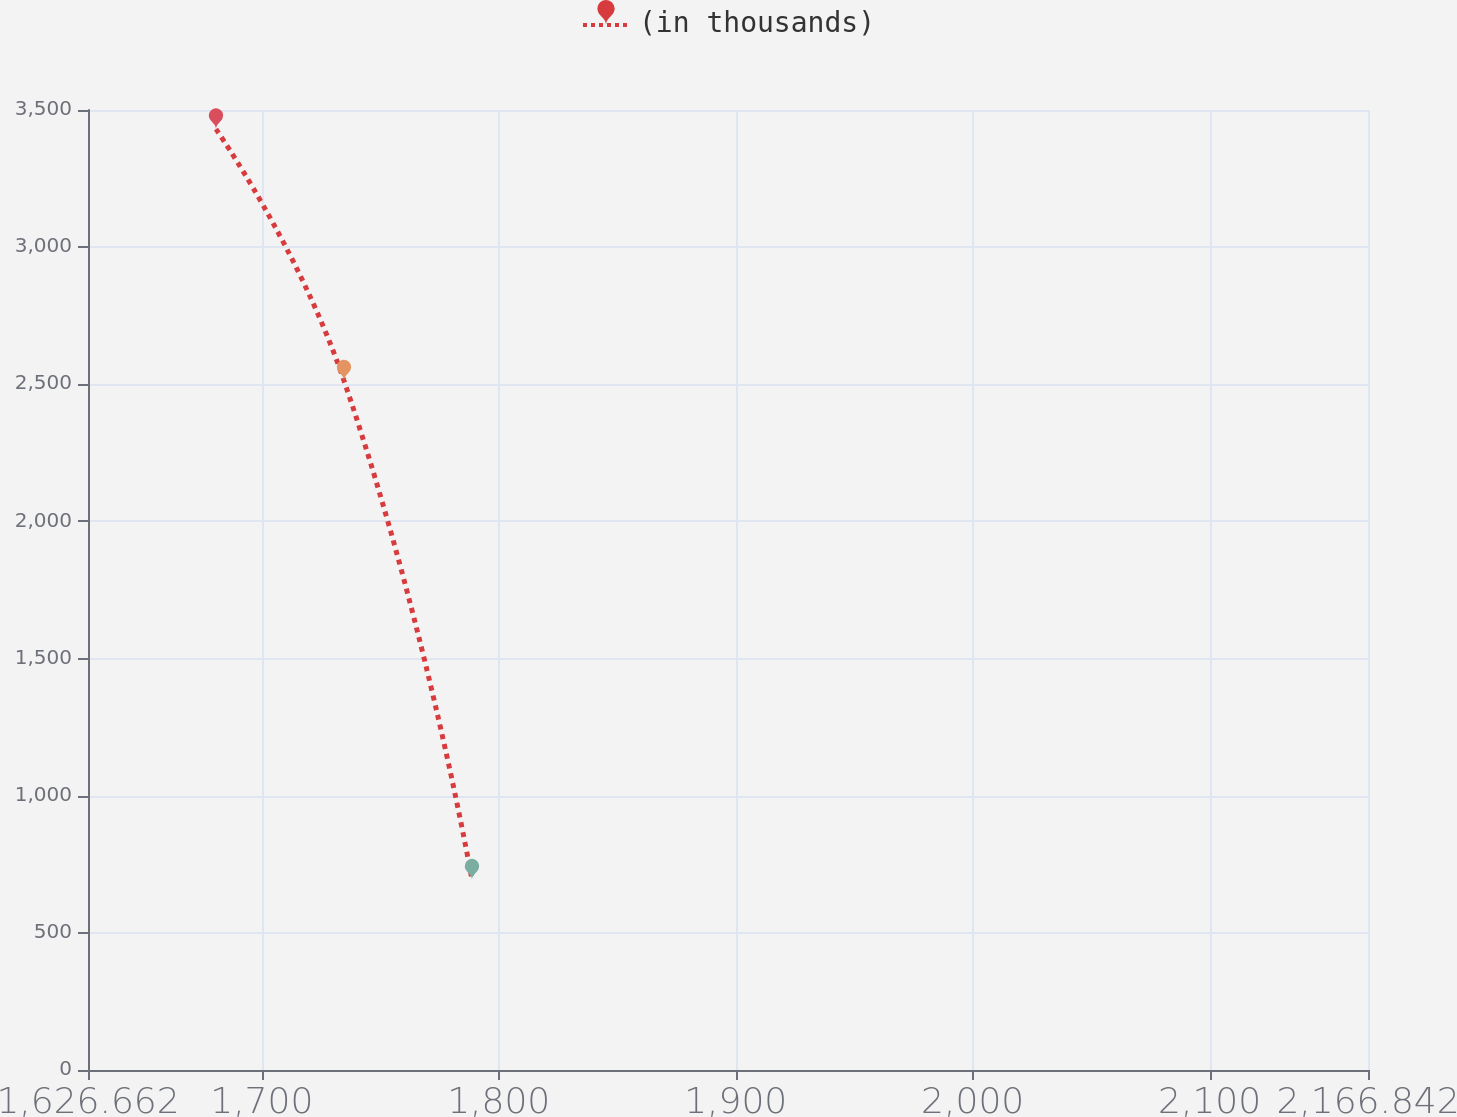Convert chart. <chart><loc_0><loc_0><loc_500><loc_500><line_chart><ecel><fcel>(in thousands)<nl><fcel>1680.68<fcel>3430.15<nl><fcel>1734.7<fcel>2512.92<nl><fcel>1788.72<fcel>693.54<nl><fcel>2220.86<fcel>237.6<nl></chart> 